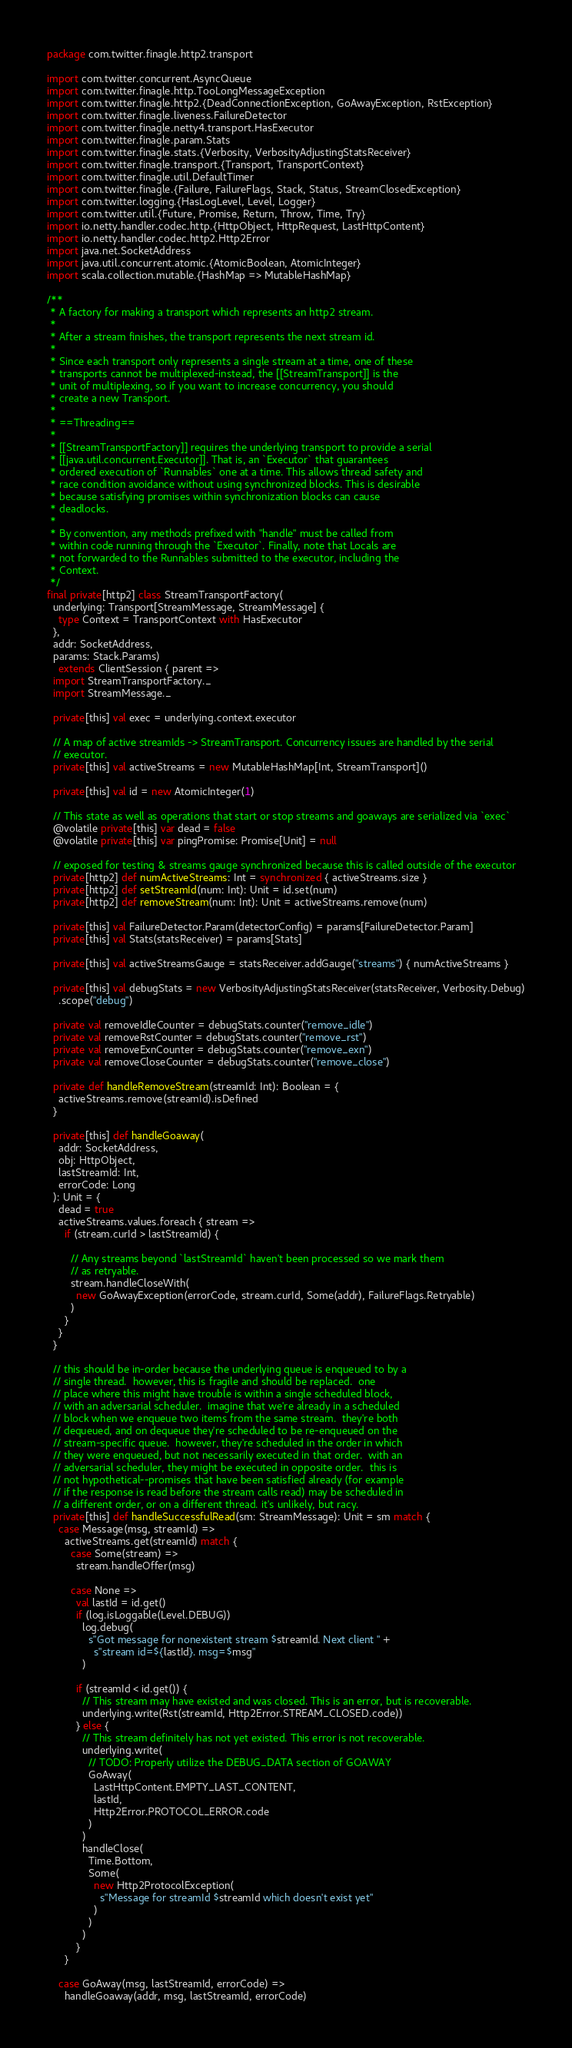<code> <loc_0><loc_0><loc_500><loc_500><_Scala_>package com.twitter.finagle.http2.transport

import com.twitter.concurrent.AsyncQueue
import com.twitter.finagle.http.TooLongMessageException
import com.twitter.finagle.http2.{DeadConnectionException, GoAwayException, RstException}
import com.twitter.finagle.liveness.FailureDetector
import com.twitter.finagle.netty4.transport.HasExecutor
import com.twitter.finagle.param.Stats
import com.twitter.finagle.stats.{Verbosity, VerbosityAdjustingStatsReceiver}
import com.twitter.finagle.transport.{Transport, TransportContext}
import com.twitter.finagle.util.DefaultTimer
import com.twitter.finagle.{Failure, FailureFlags, Stack, Status, StreamClosedException}
import com.twitter.logging.{HasLogLevel, Level, Logger}
import com.twitter.util.{Future, Promise, Return, Throw, Time, Try}
import io.netty.handler.codec.http.{HttpObject, HttpRequest, LastHttpContent}
import io.netty.handler.codec.http2.Http2Error
import java.net.SocketAddress
import java.util.concurrent.atomic.{AtomicBoolean, AtomicInteger}
import scala.collection.mutable.{HashMap => MutableHashMap}

/**
 * A factory for making a transport which represents an http2 stream.
 *
 * After a stream finishes, the transport represents the next stream id.
 *
 * Since each transport only represents a single stream at a time, one of these
 * transports cannot be multiplexed-instead, the [[StreamTransport]] is the
 * unit of multiplexing, so if you want to increase concurrency, you should
 * create a new Transport.
 *
 * ==Threading==
 *
 * [[StreamTransportFactory]] requires the underlying transport to provide a serial
 * [[java.util.concurrent.Executor]]. That is, an `Executor` that guarantees
 * ordered execution of `Runnables` one at a time. This allows thread safety and
 * race condition avoidance without using synchronized blocks. This is desirable
 * because satisfying promises within synchronization blocks can cause
 * deadlocks.
 *
 * By convention, any methods prefixed with "handle" must be called from
 * within code running through the `Executor`. Finally, note that Locals are
 * not forwarded to the Runnables submitted to the executor, including the
 * Context.
 */
final private[http2] class StreamTransportFactory(
  underlying: Transport[StreamMessage, StreamMessage] {
    type Context = TransportContext with HasExecutor
  },
  addr: SocketAddress,
  params: Stack.Params)
    extends ClientSession { parent =>
  import StreamTransportFactory._
  import StreamMessage._

  private[this] val exec = underlying.context.executor

  // A map of active streamIds -> StreamTransport. Concurrency issues are handled by the serial
  // executor.
  private[this] val activeStreams = new MutableHashMap[Int, StreamTransport]()

  private[this] val id = new AtomicInteger(1)

  // This state as well as operations that start or stop streams and goaways are serialized via `exec`
  @volatile private[this] var dead = false
  @volatile private[this] var pingPromise: Promise[Unit] = null

  // exposed for testing & streams gauge synchronized because this is called outside of the executor
  private[http2] def numActiveStreams: Int = synchronized { activeStreams.size }
  private[http2] def setStreamId(num: Int): Unit = id.set(num)
  private[http2] def removeStream(num: Int): Unit = activeStreams.remove(num)

  private[this] val FailureDetector.Param(detectorConfig) = params[FailureDetector.Param]
  private[this] val Stats(statsReceiver) = params[Stats]

  private[this] val activeStreamsGauge = statsReceiver.addGauge("streams") { numActiveStreams }

  private[this] val debugStats = new VerbosityAdjustingStatsReceiver(statsReceiver, Verbosity.Debug)
    .scope("debug")

  private val removeIdleCounter = debugStats.counter("remove_idle")
  private val removeRstCounter = debugStats.counter("remove_rst")
  private val removeExnCounter = debugStats.counter("remove_exn")
  private val removeCloseCounter = debugStats.counter("remove_close")

  private def handleRemoveStream(streamId: Int): Boolean = {
    activeStreams.remove(streamId).isDefined
  }

  private[this] def handleGoaway(
    addr: SocketAddress,
    obj: HttpObject,
    lastStreamId: Int,
    errorCode: Long
  ): Unit = {
    dead = true
    activeStreams.values.foreach { stream =>
      if (stream.curId > lastStreamId) {

        // Any streams beyond `lastStreamId` haven't been processed so we mark them
        // as retryable.
        stream.handleCloseWith(
          new GoAwayException(errorCode, stream.curId, Some(addr), FailureFlags.Retryable)
        )
      }
    }
  }

  // this should be in-order because the underlying queue is enqueued to by a
  // single thread.  however, this is fragile and should be replaced.  one
  // place where this might have trouble is within a single scheduled block,
  // with an adversarial scheduler.  imagine that we're already in a scheduled
  // block when we enqueue two items from the same stream.  they're both
  // dequeued, and on dequeue they're scheduled to be re-enqueued on the
  // stream-specific queue.  however, they're scheduled in the order in which
  // they were enqueued, but not necessarily executed in that order.  with an
  // adversarial scheduler, they might be executed in opposite order.  this is
  // not hypothetical--promises that have been satisfied already (for example
  // if the response is read before the stream calls read) may be scheduled in
  // a different order, or on a different thread. it's unlikely, but racy.
  private[this] def handleSuccessfulRead(sm: StreamMessage): Unit = sm match {
    case Message(msg, streamId) =>
      activeStreams.get(streamId) match {
        case Some(stream) =>
          stream.handleOffer(msg)

        case None =>
          val lastId = id.get()
          if (log.isLoggable(Level.DEBUG))
            log.debug(
              s"Got message for nonexistent stream $streamId. Next client " +
                s"stream id=${lastId}. msg=$msg"
            )

          if (streamId < id.get()) {
            // This stream may have existed and was closed. This is an error, but is recoverable.
            underlying.write(Rst(streamId, Http2Error.STREAM_CLOSED.code))
          } else {
            // This stream definitely has not yet existed. This error is not recoverable.
            underlying.write(
              // TODO: Properly utilize the DEBUG_DATA section of GOAWAY
              GoAway(
                LastHttpContent.EMPTY_LAST_CONTENT,
                lastId,
                Http2Error.PROTOCOL_ERROR.code
              )
            )
            handleClose(
              Time.Bottom,
              Some(
                new Http2ProtocolException(
                  s"Message for streamId $streamId which doesn't exist yet"
                )
              )
            )
          }
      }

    case GoAway(msg, lastStreamId, errorCode) =>
      handleGoaway(addr, msg, lastStreamId, errorCode)
</code> 